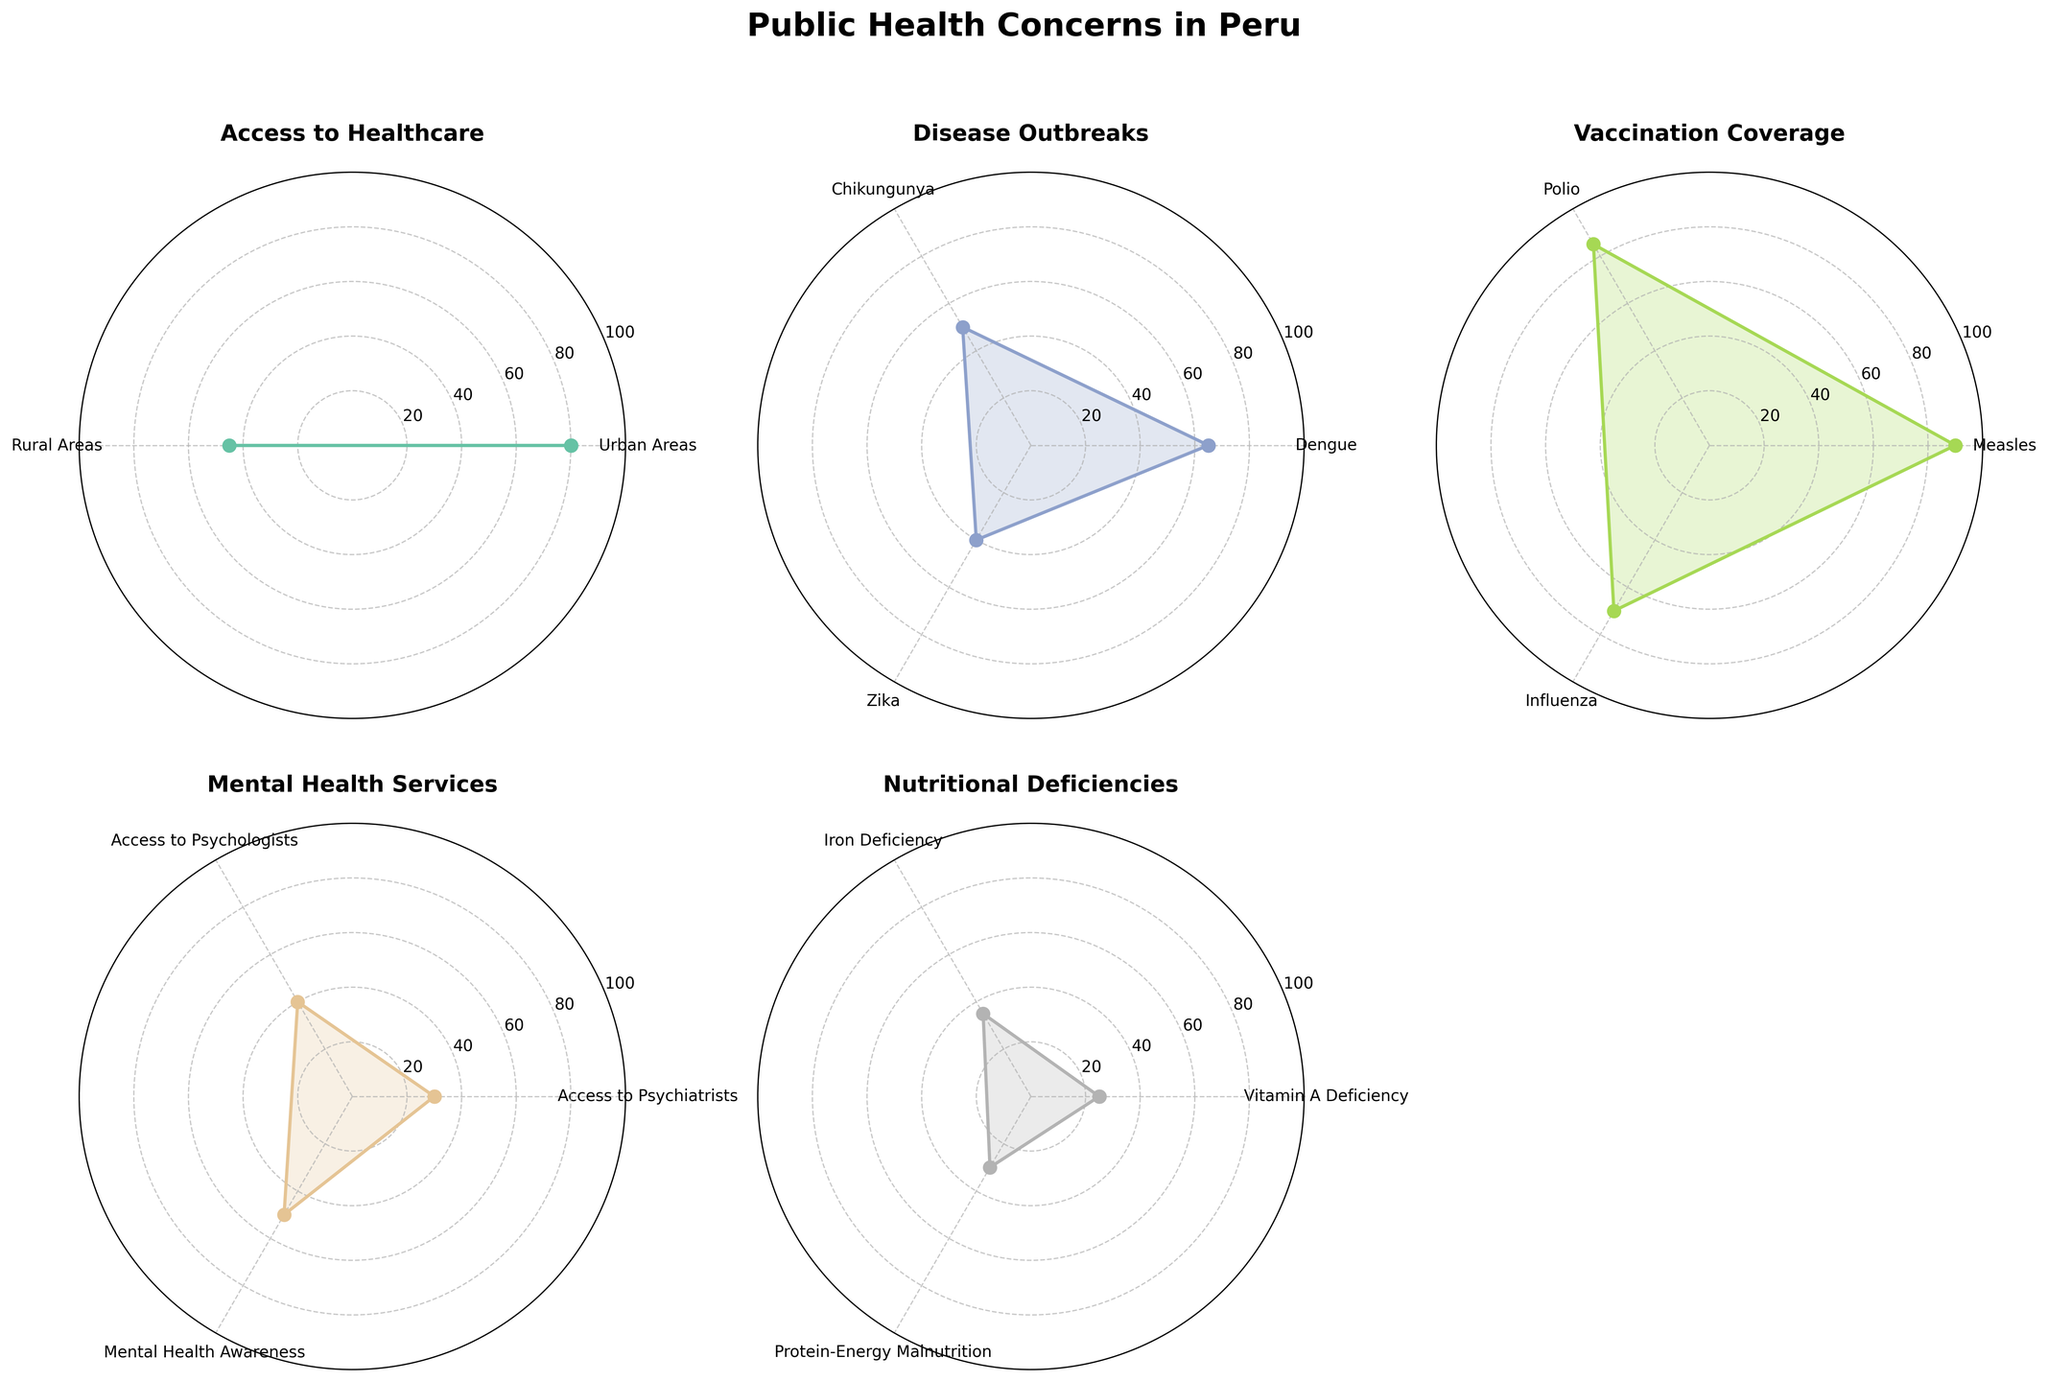Which category has the highest value in urban areas for access to healthcare? The radar chart shows that the value for Access to Healthcare in Urban Areas is the highest at 80.
Answer: Access to Healthcare What's the difference in access to healthcare between urban and rural areas? The radar chart indicates that Access to Healthcare in Urban Areas has a value of 80, while Rural Areas have a value of 45. The difference is calculated as 80 - 45 = 35.
Answer: 35 Which disease has the highest outbreak rate? Looking at the radar chart for Disease Outbreaks, Dengue has the highest value at 65 compared to Chikungunya (50) and Zika (40).
Answer: Dengue Compare the vaccination coverage rates for measles and influenza. Which one is higher and by how much? The chart shows that the vaccination coverage for Measles is 90, while for Influenza, it is 70. The difference is 90 - 70 = 20.
Answer: Measles by 20 Which mental health service has the lowest access value? The radar chart under Mental Health Services shows that Access to Psychiatrists has the lowest value at 30.
Answer: Access to Psychiatrists What is the average value for nutritional deficiencies? The radar chart shows values for Vitamin A Deficiency (25), Iron Deficiency (35), and Protein-Energy Malnutrition (30). The average is calculated as (25 + 35 + 30)/3 = 30.
Answer: 30 In the category of Vaccination Coverage, which has the second-highest value? The radar chart for Vaccination Coverage shows that Measles has the value of 90, Polio has 85, and Influenza has 70. So, Polio has the second-highest value at 85.
Answer: Polio Which category has the most evenly distributed values among its subcategories? By visually scanning the radar charts, Mental Health Services appears to have the most evenly distributed values among its subcategories: Access to Psychiatrists (30), Access to Psychologists (40), and Mental Health Awareness (50).
Answer: Mental Health Services How does the access to healthcare in rural areas compare to the access to psychologists in mental health services? The radar chart shows that Access to Healthcare in Rural Areas has a value of 45, while Access to Psychologists in Mental Health Services has a value of 40. The access to healthcare in rural areas is slightly higher.
Answer: Higher 